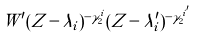<formula> <loc_0><loc_0><loc_500><loc_500>W ^ { \prime } ( Z - \lambda _ { i } ) ^ { - \gamma _ { 2 } ^ { i } } ( Z - \lambda _ { i } ^ { \prime } ) ^ { - \gamma _ { 2 } ^ { i ^ { \prime } } }</formula> 